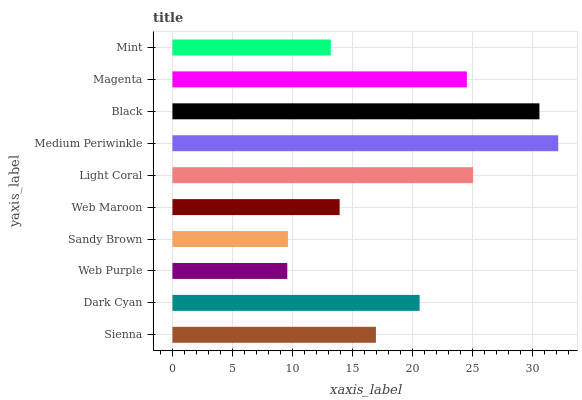Is Web Purple the minimum?
Answer yes or no. Yes. Is Medium Periwinkle the maximum?
Answer yes or no. Yes. Is Dark Cyan the minimum?
Answer yes or no. No. Is Dark Cyan the maximum?
Answer yes or no. No. Is Dark Cyan greater than Sienna?
Answer yes or no. Yes. Is Sienna less than Dark Cyan?
Answer yes or no. Yes. Is Sienna greater than Dark Cyan?
Answer yes or no. No. Is Dark Cyan less than Sienna?
Answer yes or no. No. Is Dark Cyan the high median?
Answer yes or no. Yes. Is Sienna the low median?
Answer yes or no. Yes. Is Magenta the high median?
Answer yes or no. No. Is Light Coral the low median?
Answer yes or no. No. 